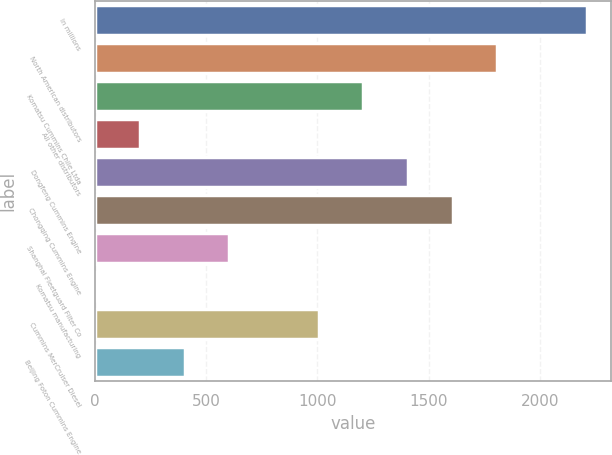Convert chart to OTSL. <chart><loc_0><loc_0><loc_500><loc_500><bar_chart><fcel>In millions<fcel>North American distributors<fcel>Komatsu Cummins Chile Ltda<fcel>All other distributors<fcel>Dongfeng Cummins Engine<fcel>Chongqing Cummins Engine<fcel>Shanghai Fleetguard Filter Co<fcel>Komatsu manufacturing<fcel>Cummins MerCruiser Diesel<fcel>Beijing Foton Cummins Engine<nl><fcel>2209.7<fcel>1808.3<fcel>1206.2<fcel>202.7<fcel>1406.9<fcel>1607.6<fcel>604.1<fcel>2<fcel>1005.5<fcel>403.4<nl></chart> 